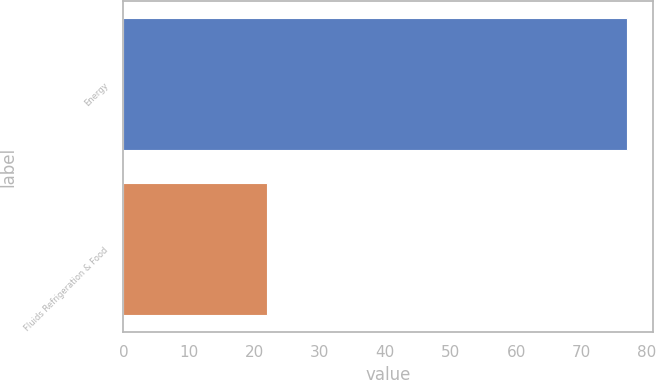Convert chart to OTSL. <chart><loc_0><loc_0><loc_500><loc_500><bar_chart><fcel>Energy<fcel>Fluids Refrigeration & Food<nl><fcel>77<fcel>22<nl></chart> 